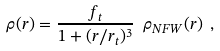<formula> <loc_0><loc_0><loc_500><loc_500>\rho ( r ) = \frac { f _ { t } } { 1 + ( r / r _ { t } ) ^ { 3 } } \ \rho _ { N F W } ( r ) \ ,</formula> 